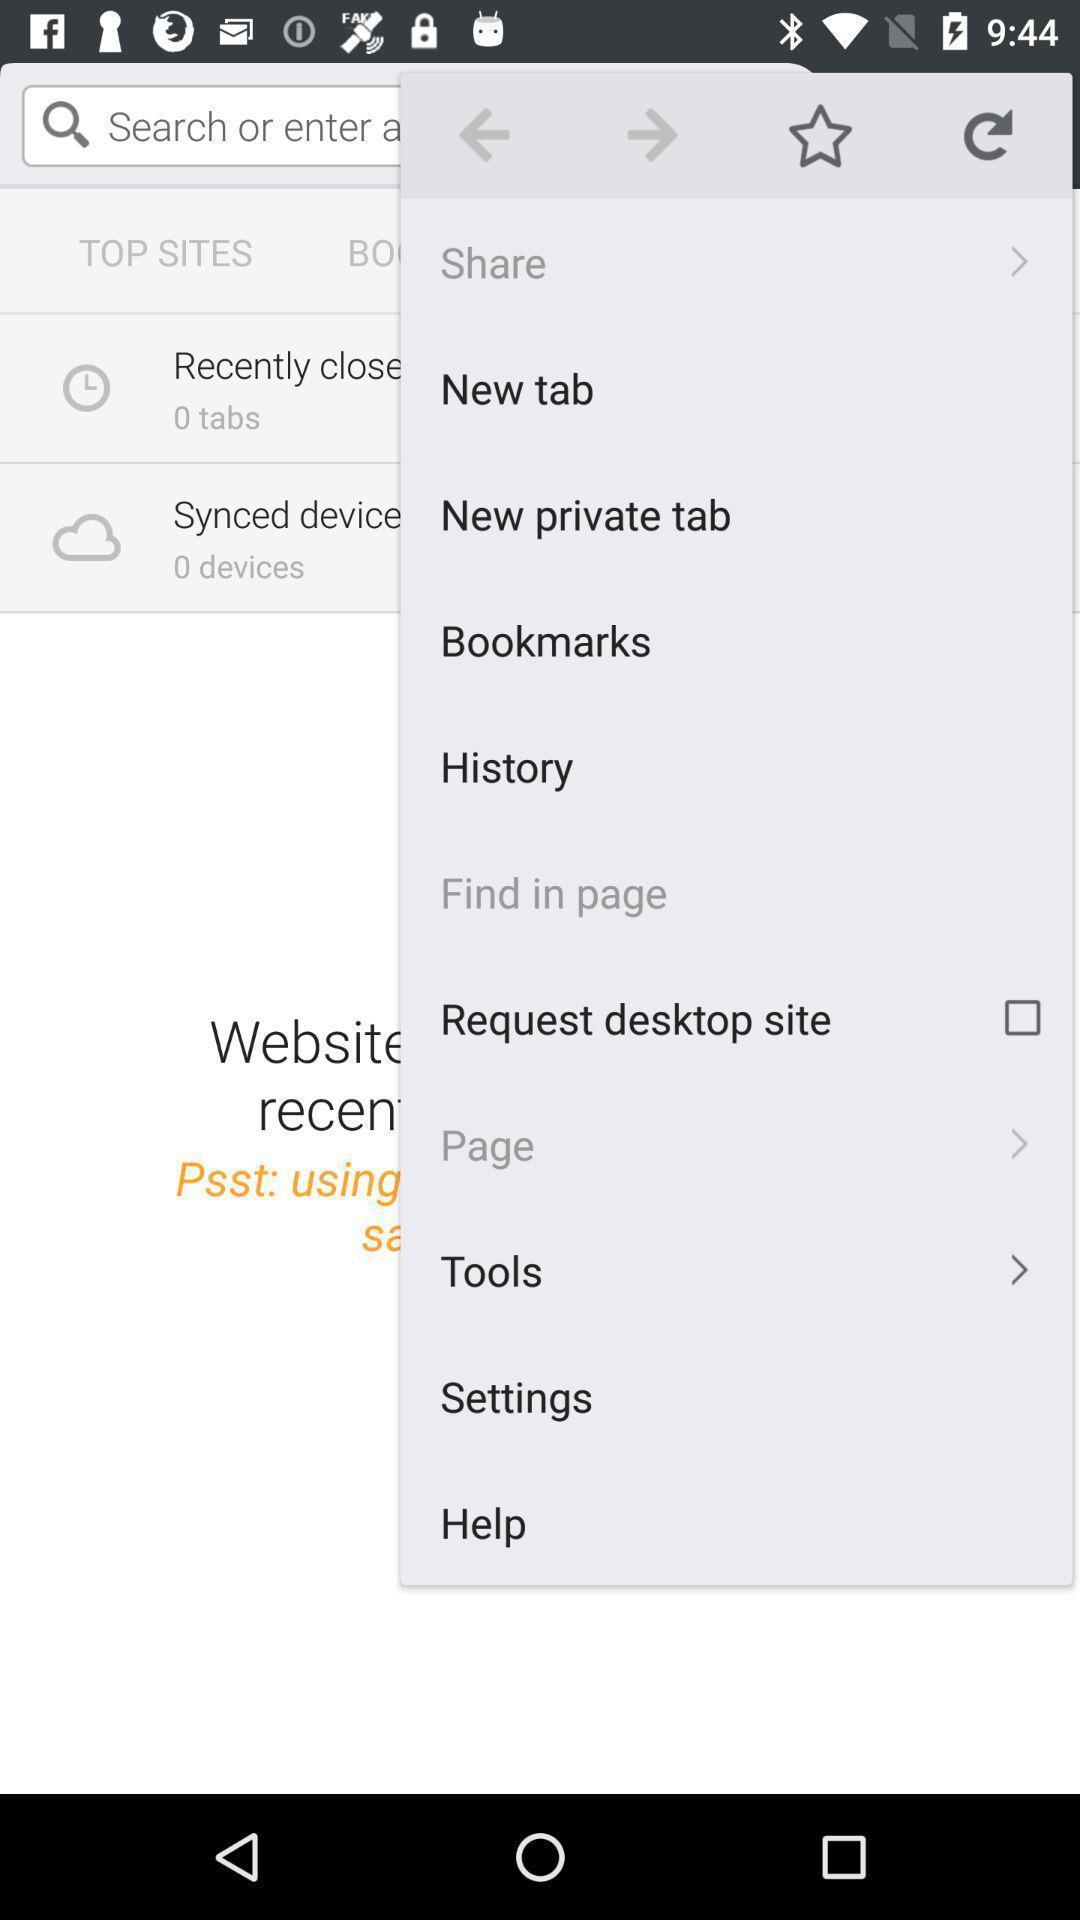Describe this image in words. Screen displaying multiple setting options in browser page. 